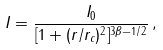Convert formula to latex. <formula><loc_0><loc_0><loc_500><loc_500>I = \frac { I _ { 0 } } { [ 1 + ( r / r _ { c } ) ^ { 2 } ] ^ { 3 \beta - 1 / 2 } } \, ,</formula> 